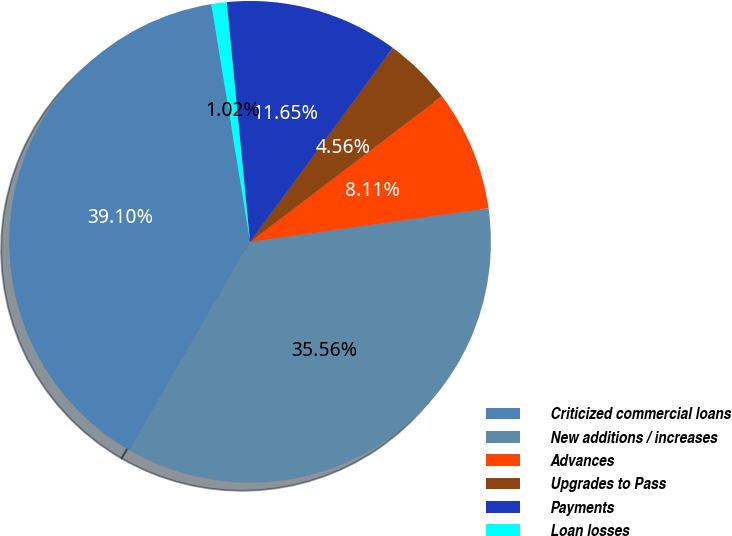<chart> <loc_0><loc_0><loc_500><loc_500><pie_chart><fcel>Criticized commercial loans<fcel>New additions / increases<fcel>Advances<fcel>Upgrades to Pass<fcel>Payments<fcel>Loan losses<nl><fcel>39.1%<fcel>35.56%<fcel>8.11%<fcel>4.56%<fcel>11.65%<fcel>1.02%<nl></chart> 